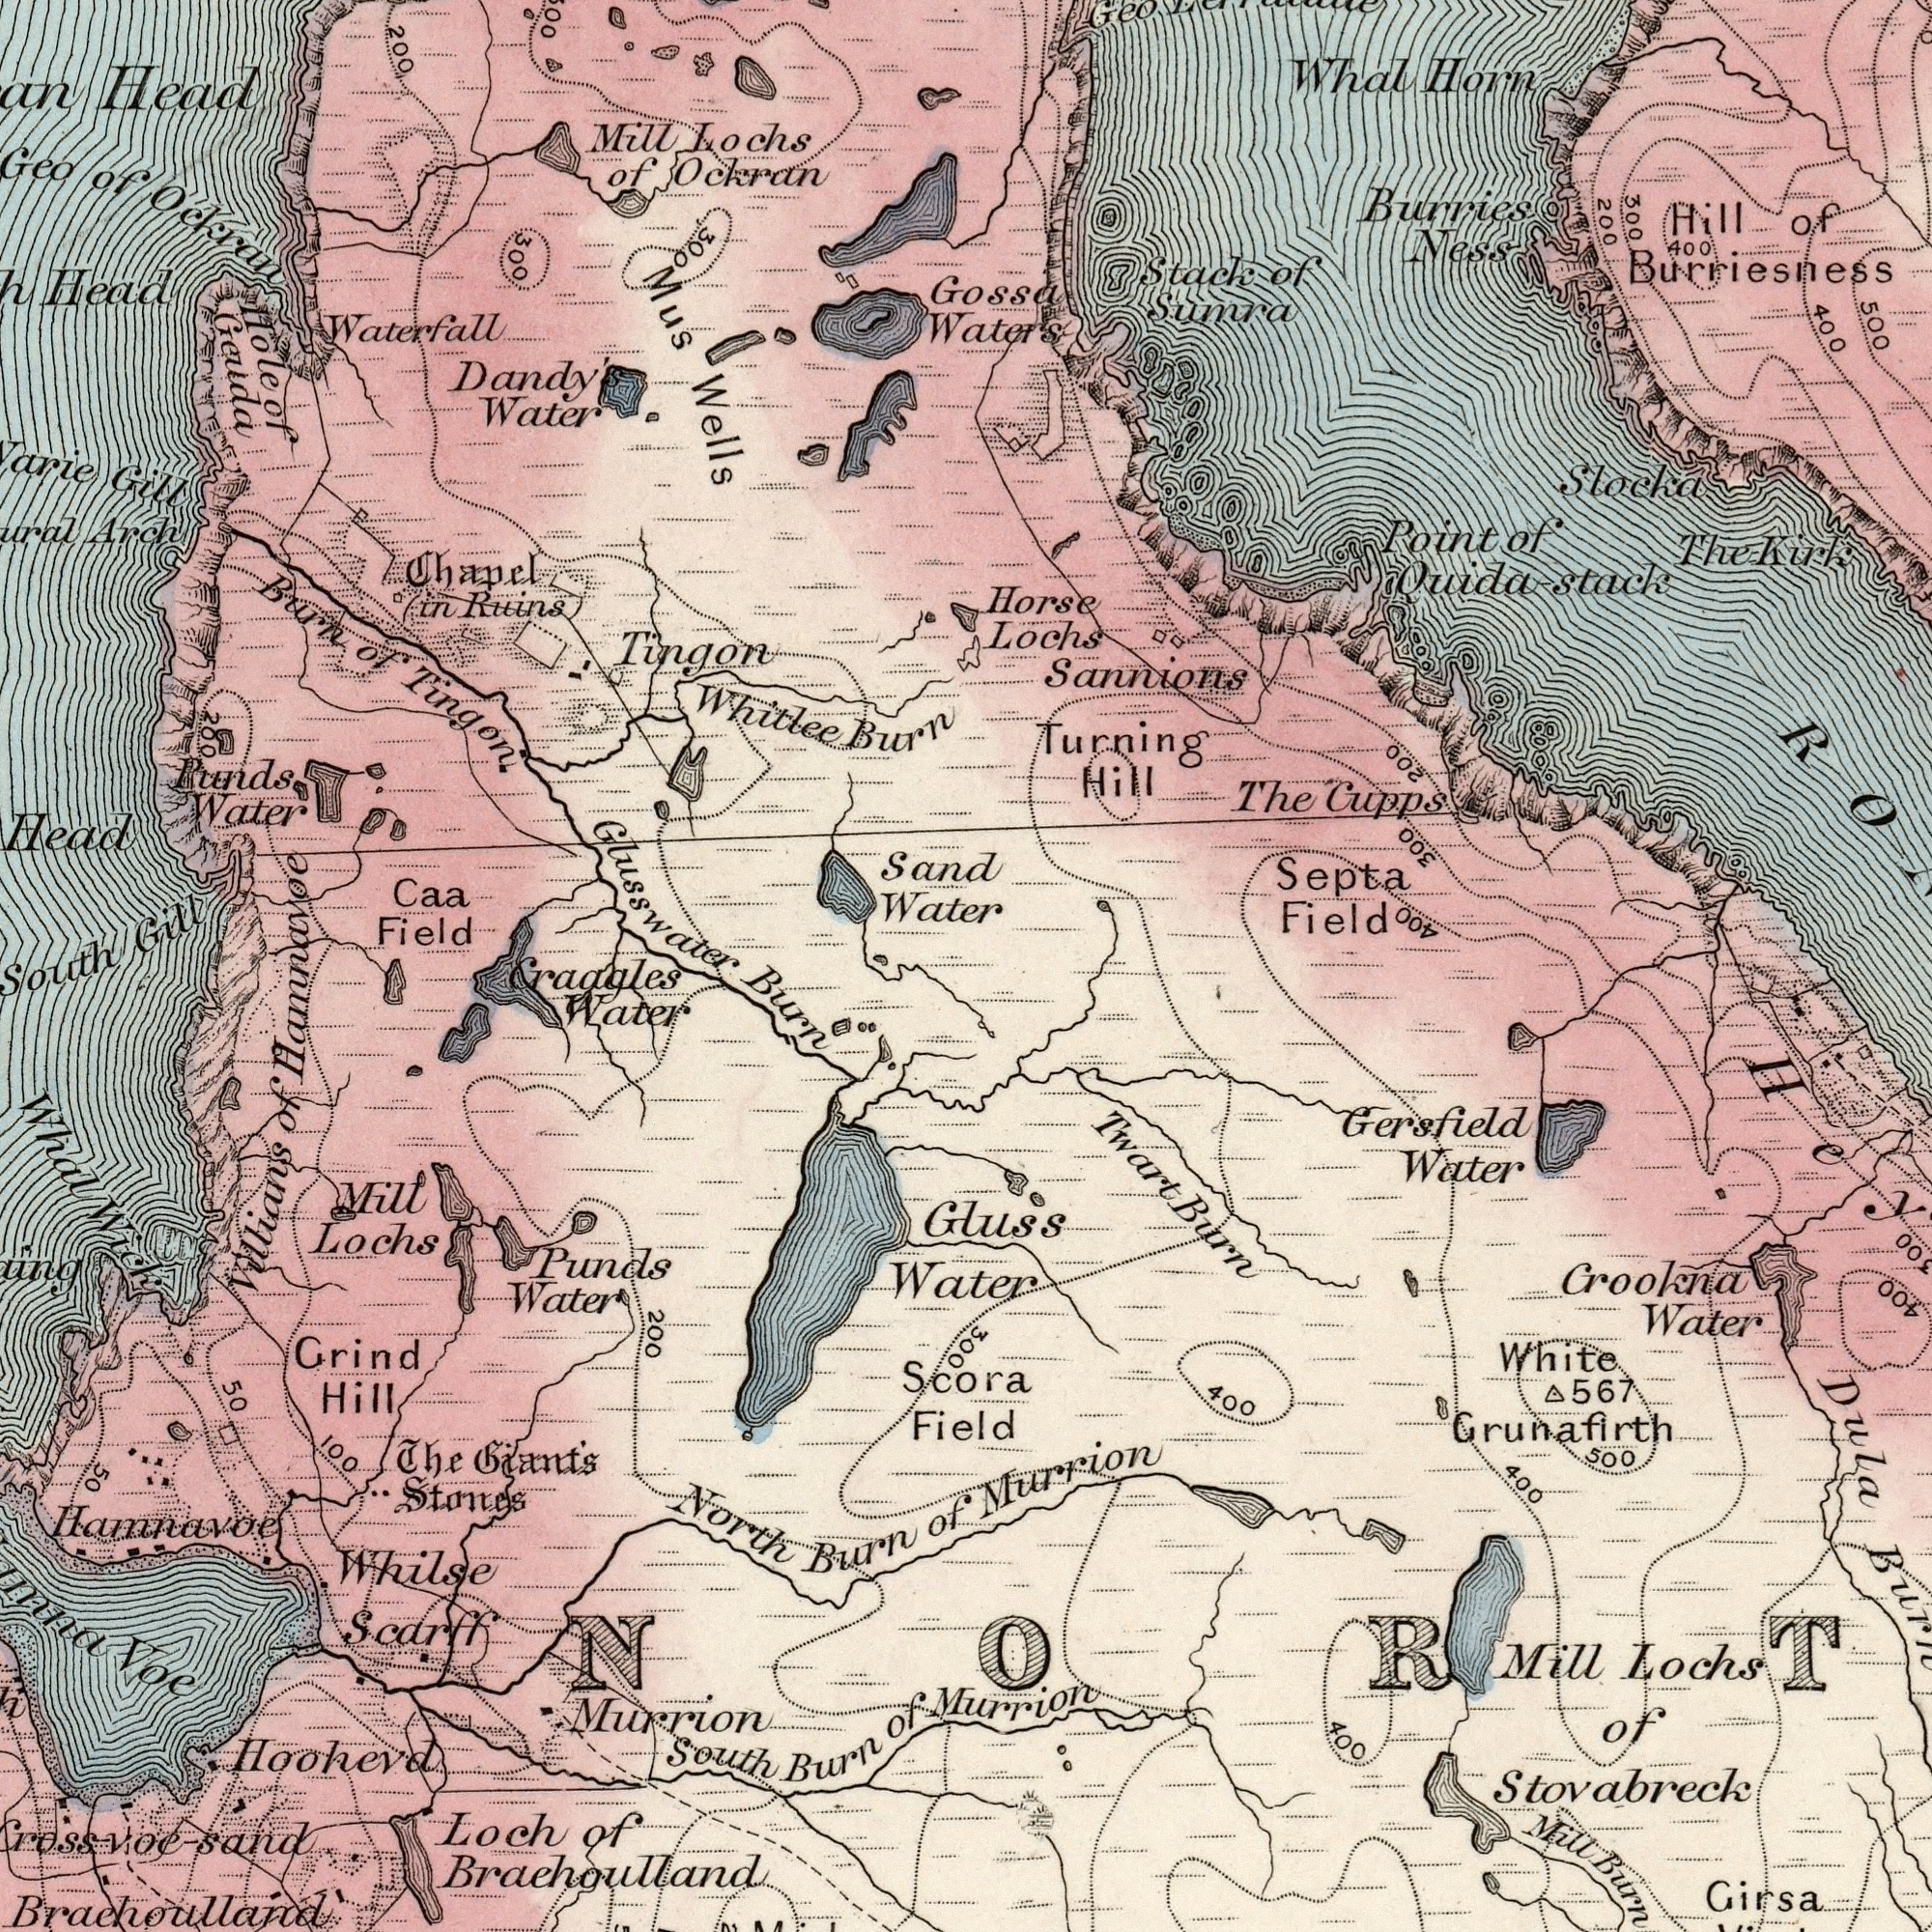What text is visible in the lower-right corner? Field Scora Grunafirth Stovabreck Dula Water Gersfield Girsa White Mill Murrion Crookna Lochs 400 Gluss 400 Murrion of Water 500 400 567 Twart Burn Mill Burn 300 400 300 What text is shown in the top-left quadrant? Head Whitlee Waterfall Ockran Tingon Head Water Water Punds Ockran Gill Chapel Ruins) Field of Gill Tingon Mill Mus Caa Water Geuda Geo Burn 200 Hole Wells of Dandy's Glusswater Burn Sand Arch Hamnavoe Lochs (in Head of South 300 200 300 of What text is shown in the bottom-left quadrant? North Hoohevd Whilse Loch Stones Water Grind Lochs Scarff Water Water South Villians Craggles Voe Hill Crossvoe-sand Giant's Mill Burn Murrion Burn Whal of of The 50 Punds 100 of 200 Brachoulland Burn Hamnavoe of Brachoulland 50 Wick What text appears in the top-right area of the image? Water's Sannions Septa Horse Sumra Burries Lochs Slocka Horn Ness The Whal Quida-stack Stack Hill Hill Field Turning 500 200 400 of Gossa Kirk Burriesness Point 400 300 The Cupps of of 400 300 200 Geo 